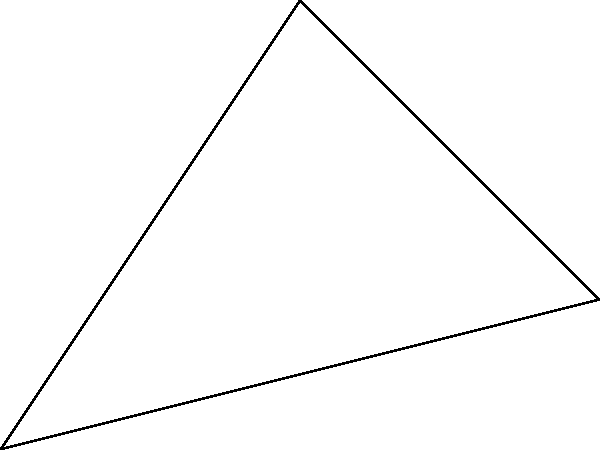In the facade of St. Johann Basilica in Saarbrücken, two intersecting arches form a characteristic baroque element. If the arches intersect at points A and B, and their centers are at O and the midpoint of AB respectively, what is the angle $\theta$ between these arches at their intersection point O? To solve this problem, we'll follow these steps:

1) In a circle, the angle between a tangent and a chord at the point of contact is equal to the angle in the alternate segment.

2) In our case, OA and OB are radii of the first arch, and they are tangent to the second arch at A and B respectively.

3) The angle between these tangents (OA and OB) at O is the same as the angle between the arches at their intersection.

4) In the triangle OAB:
   - OA and OB are radii of the first arch, so they are equal.
   - The perpendicular bisector of AB passes through O (as O is the center of the first arch) and the center of the second arch (as it's the midpoint of AB).
   
5) This means that triangle OAB is isosceles, and the perpendicular bisector of AB bisects angle AOB.

6) Therefore, angle AOB = $2\theta$.

7) In an isosceles triangle, we know that:
   $$2\theta + \angle ABO + \angle BAO = 180°$$

8) Since OA and OB are tangent to the second arch, $\angle ABO = \angle BAO = 90°$.

9) Substituting this in our equation:
   $$2\theta + 90° + 90° = 180°$$
   $$2\theta = 180° - 180° = 0°$$
   $$\theta = 0°$$

Thus, the angle between the arches at their intersection is 0°, meaning the arches are tangent to each other at this point.
Answer: $0°$ 